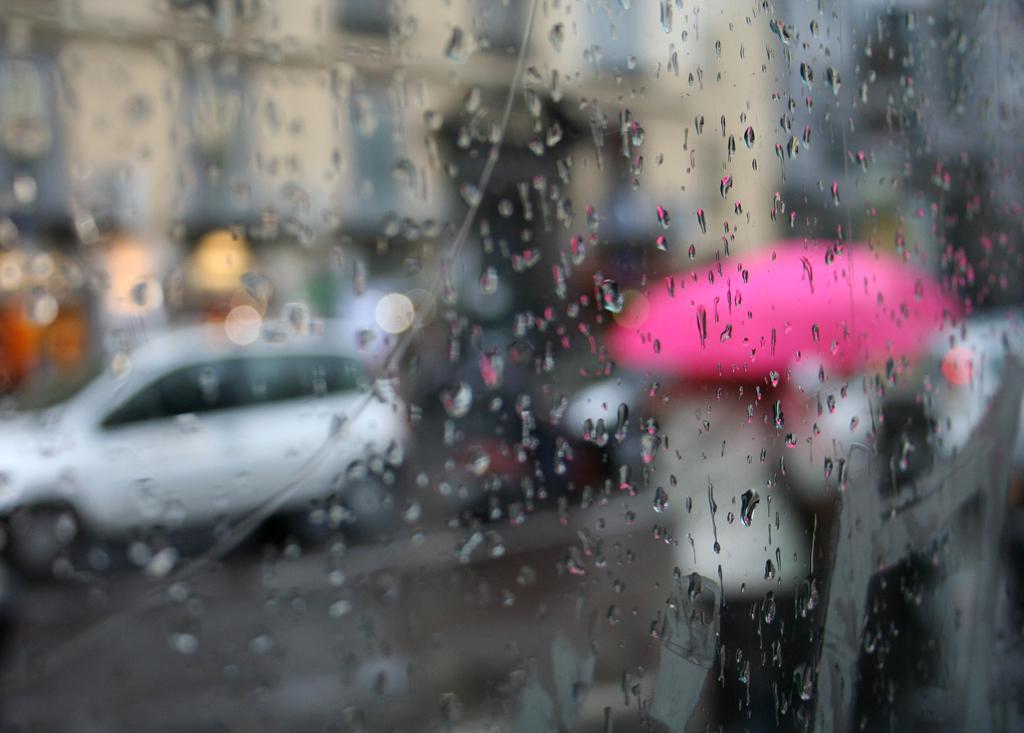How would you summarize this image in a sentence or two? In this picture there is a glass which has water droplets on it and there is a car and a person holding a pink color umbrella in the background. 